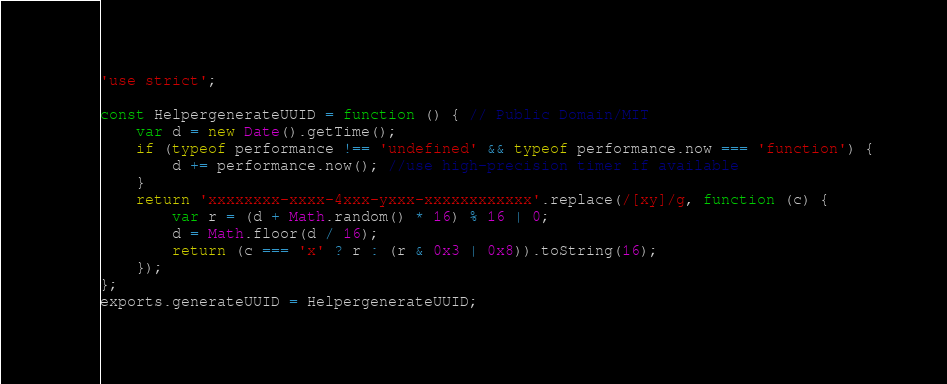<code> <loc_0><loc_0><loc_500><loc_500><_JavaScript_>'use strict';

const HelpergenerateUUID = function () { // Public Domain/MIT
	var d = new Date().getTime();
	if (typeof performance !== 'undefined' && typeof performance.now === 'function') {
		d += performance.now(); //use high-precision timer if available
	}
	return 'xxxxxxxx-xxxx-4xxx-yxxx-xxxxxxxxxxxx'.replace(/[xy]/g, function (c) {
		var r = (d + Math.random() * 16) % 16 | 0;
		d = Math.floor(d / 16);
		return (c === 'x' ? r : (r & 0x3 | 0x8)).toString(16);
	});
};
exports.generateUUID = HelpergenerateUUID;</code> 